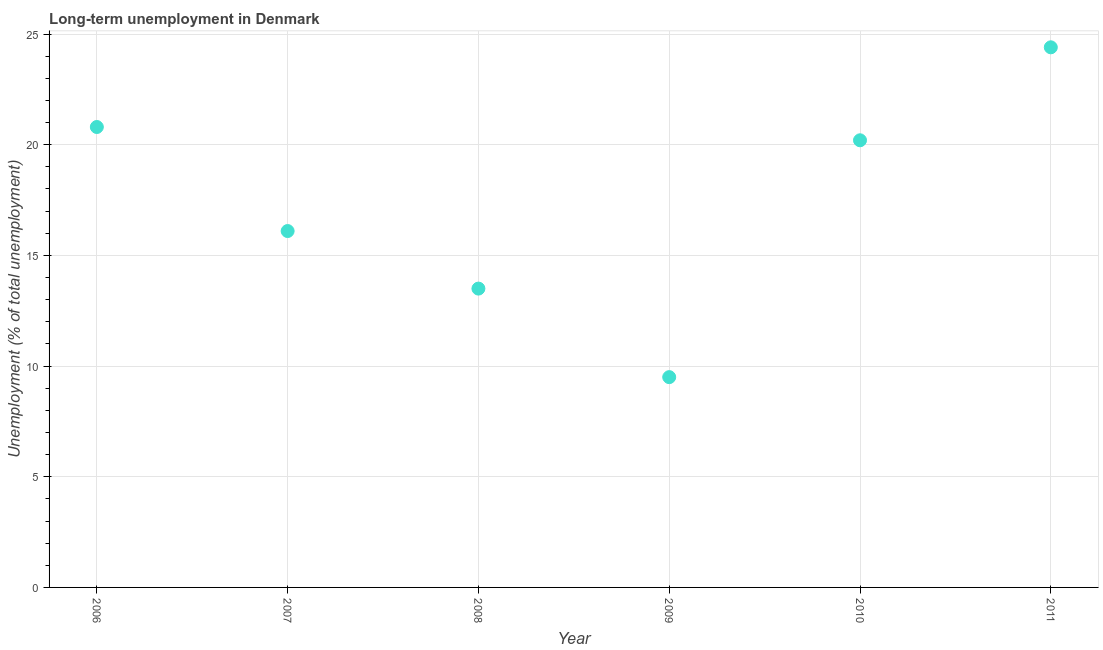What is the long-term unemployment in 2010?
Give a very brief answer. 20.2. Across all years, what is the maximum long-term unemployment?
Your answer should be very brief. 24.4. Across all years, what is the minimum long-term unemployment?
Your answer should be very brief. 9.5. In which year was the long-term unemployment minimum?
Keep it short and to the point. 2009. What is the sum of the long-term unemployment?
Give a very brief answer. 104.5. What is the difference between the long-term unemployment in 2006 and 2007?
Your answer should be very brief. 4.7. What is the average long-term unemployment per year?
Your response must be concise. 17.42. What is the median long-term unemployment?
Ensure brevity in your answer.  18.15. What is the ratio of the long-term unemployment in 2007 to that in 2011?
Your answer should be very brief. 0.66. Is the long-term unemployment in 2010 less than that in 2011?
Provide a short and direct response. Yes. Is the difference between the long-term unemployment in 2009 and 2010 greater than the difference between any two years?
Provide a succinct answer. No. What is the difference between the highest and the second highest long-term unemployment?
Your answer should be very brief. 3.6. Is the sum of the long-term unemployment in 2008 and 2009 greater than the maximum long-term unemployment across all years?
Make the answer very short. No. What is the difference between the highest and the lowest long-term unemployment?
Your response must be concise. 14.9. In how many years, is the long-term unemployment greater than the average long-term unemployment taken over all years?
Your response must be concise. 3. Does the long-term unemployment monotonically increase over the years?
Your answer should be very brief. No. How many dotlines are there?
Give a very brief answer. 1. What is the difference between two consecutive major ticks on the Y-axis?
Make the answer very short. 5. Does the graph contain any zero values?
Ensure brevity in your answer.  No. What is the title of the graph?
Offer a terse response. Long-term unemployment in Denmark. What is the label or title of the Y-axis?
Your answer should be compact. Unemployment (% of total unemployment). What is the Unemployment (% of total unemployment) in 2006?
Ensure brevity in your answer.  20.8. What is the Unemployment (% of total unemployment) in 2007?
Ensure brevity in your answer.  16.1. What is the Unemployment (% of total unemployment) in 2009?
Offer a terse response. 9.5. What is the Unemployment (% of total unemployment) in 2010?
Your answer should be very brief. 20.2. What is the Unemployment (% of total unemployment) in 2011?
Keep it short and to the point. 24.4. What is the difference between the Unemployment (% of total unemployment) in 2006 and 2008?
Provide a short and direct response. 7.3. What is the difference between the Unemployment (% of total unemployment) in 2006 and 2009?
Your answer should be compact. 11.3. What is the difference between the Unemployment (% of total unemployment) in 2006 and 2010?
Give a very brief answer. 0.6. What is the difference between the Unemployment (% of total unemployment) in 2007 and 2008?
Offer a terse response. 2.6. What is the difference between the Unemployment (% of total unemployment) in 2007 and 2009?
Offer a terse response. 6.6. What is the difference between the Unemployment (% of total unemployment) in 2007 and 2010?
Make the answer very short. -4.1. What is the difference between the Unemployment (% of total unemployment) in 2007 and 2011?
Your answer should be compact. -8.3. What is the difference between the Unemployment (% of total unemployment) in 2008 and 2009?
Your answer should be compact. 4. What is the difference between the Unemployment (% of total unemployment) in 2008 and 2010?
Provide a short and direct response. -6.7. What is the difference between the Unemployment (% of total unemployment) in 2009 and 2010?
Your answer should be very brief. -10.7. What is the difference between the Unemployment (% of total unemployment) in 2009 and 2011?
Keep it short and to the point. -14.9. What is the ratio of the Unemployment (% of total unemployment) in 2006 to that in 2007?
Offer a terse response. 1.29. What is the ratio of the Unemployment (% of total unemployment) in 2006 to that in 2008?
Provide a succinct answer. 1.54. What is the ratio of the Unemployment (% of total unemployment) in 2006 to that in 2009?
Ensure brevity in your answer.  2.19. What is the ratio of the Unemployment (% of total unemployment) in 2006 to that in 2011?
Provide a succinct answer. 0.85. What is the ratio of the Unemployment (% of total unemployment) in 2007 to that in 2008?
Make the answer very short. 1.19. What is the ratio of the Unemployment (% of total unemployment) in 2007 to that in 2009?
Your response must be concise. 1.7. What is the ratio of the Unemployment (% of total unemployment) in 2007 to that in 2010?
Your response must be concise. 0.8. What is the ratio of the Unemployment (% of total unemployment) in 2007 to that in 2011?
Make the answer very short. 0.66. What is the ratio of the Unemployment (% of total unemployment) in 2008 to that in 2009?
Provide a succinct answer. 1.42. What is the ratio of the Unemployment (% of total unemployment) in 2008 to that in 2010?
Offer a very short reply. 0.67. What is the ratio of the Unemployment (% of total unemployment) in 2008 to that in 2011?
Provide a succinct answer. 0.55. What is the ratio of the Unemployment (% of total unemployment) in 2009 to that in 2010?
Offer a very short reply. 0.47. What is the ratio of the Unemployment (% of total unemployment) in 2009 to that in 2011?
Provide a succinct answer. 0.39. What is the ratio of the Unemployment (% of total unemployment) in 2010 to that in 2011?
Ensure brevity in your answer.  0.83. 